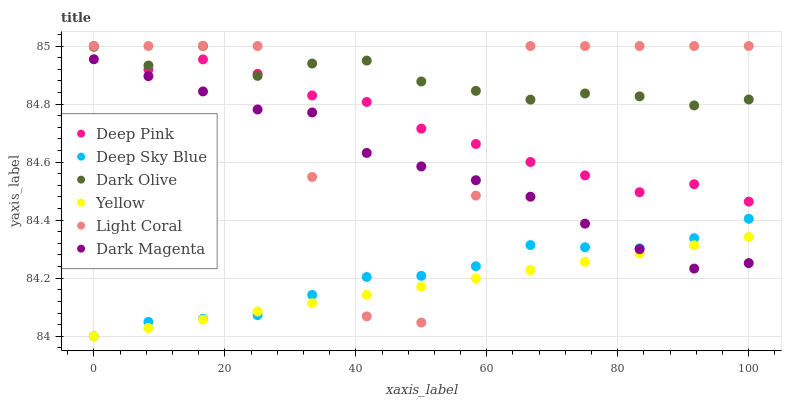Does Yellow have the minimum area under the curve?
Answer yes or no. Yes. Does Dark Olive have the maximum area under the curve?
Answer yes or no. Yes. Does Dark Magenta have the minimum area under the curve?
Answer yes or no. No. Does Dark Magenta have the maximum area under the curve?
Answer yes or no. No. Is Yellow the smoothest?
Answer yes or no. Yes. Is Light Coral the roughest?
Answer yes or no. Yes. Is Dark Magenta the smoothest?
Answer yes or no. No. Is Dark Magenta the roughest?
Answer yes or no. No. Does Yellow have the lowest value?
Answer yes or no. Yes. Does Dark Magenta have the lowest value?
Answer yes or no. No. Does Light Coral have the highest value?
Answer yes or no. Yes. Does Dark Magenta have the highest value?
Answer yes or no. No. Is Deep Sky Blue less than Deep Pink?
Answer yes or no. Yes. Is Deep Pink greater than Dark Magenta?
Answer yes or no. Yes. Does Dark Magenta intersect Deep Sky Blue?
Answer yes or no. Yes. Is Dark Magenta less than Deep Sky Blue?
Answer yes or no. No. Is Dark Magenta greater than Deep Sky Blue?
Answer yes or no. No. Does Deep Sky Blue intersect Deep Pink?
Answer yes or no. No. 